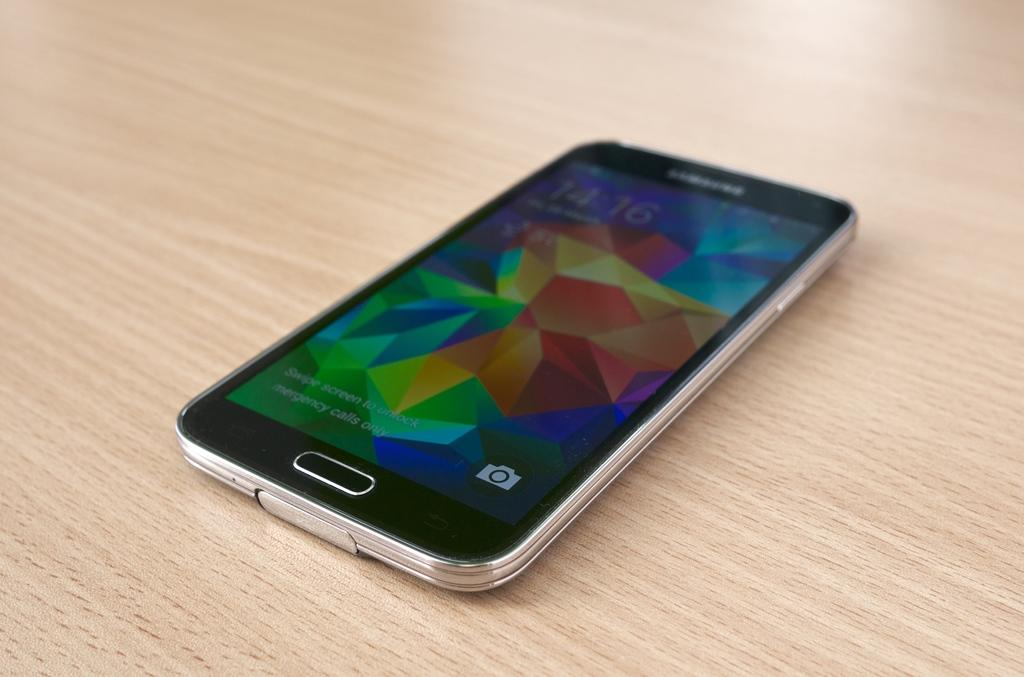<image>
Relay a brief, clear account of the picture shown. A Samsung phone is sitting on a wooden table. 